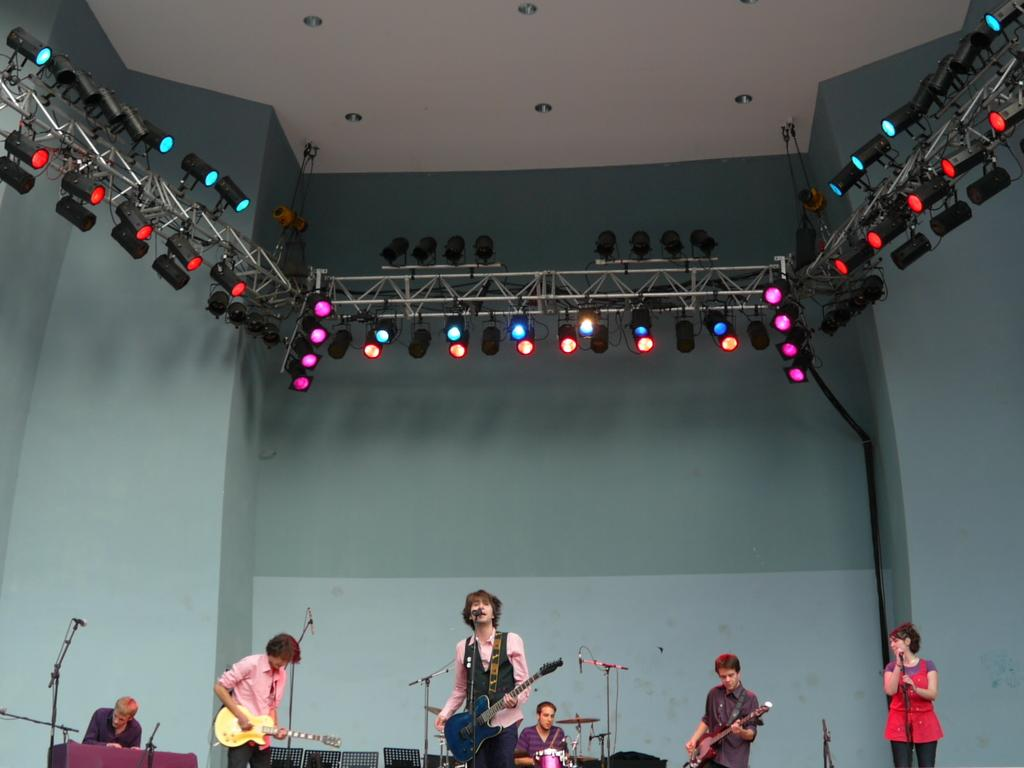What is the main activity of the group of persons in the image? The group of persons is playing music. Can you describe the setting of the image? There are lights visible on the roof in the image. What month is it in the image? The month cannot be determined from the image, as there is no information about the date or time of year. Is there a church present in the image? There is no church visible in the image; it only shows a group of persons playing music and lights on the roof. 